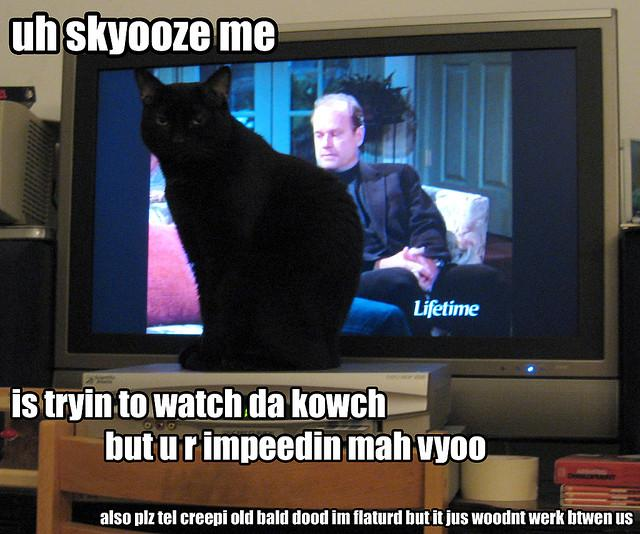What piece of furniture is misspelled here? couch 